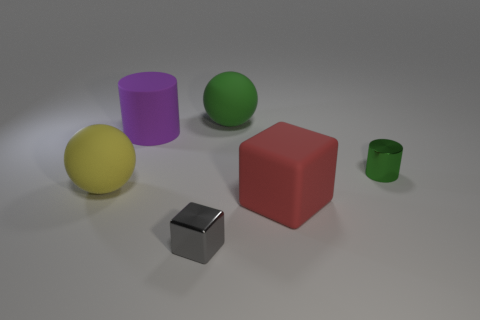Subtract all yellow cylinders. Subtract all brown spheres. How many cylinders are left? 2 Add 1 red matte objects. How many objects exist? 7 Subtract all spheres. How many objects are left? 4 Subtract all small purple blocks. Subtract all purple objects. How many objects are left? 5 Add 2 small green metallic cylinders. How many small green metallic cylinders are left? 3 Add 1 tiny blocks. How many tiny blocks exist? 2 Subtract 1 green cylinders. How many objects are left? 5 